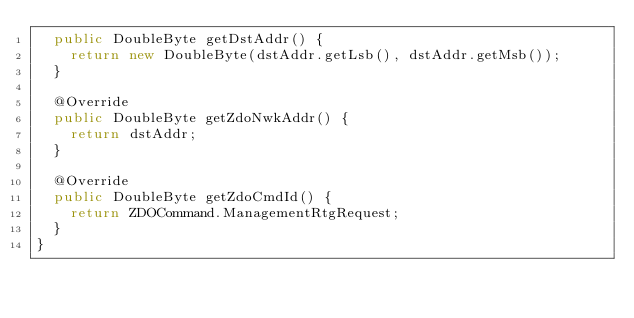<code> <loc_0><loc_0><loc_500><loc_500><_Java_>	public DoubleByte getDstAddr() {
		return new DoubleByte(dstAddr.getLsb(), dstAddr.getMsb());
	}

	@Override
	public DoubleByte getZdoNwkAddr() {
		return dstAddr;
	}

	@Override
	public DoubleByte getZdoCmdId() {
		return ZDOCommand.ManagementRtgRequest;
	}
}
</code> 